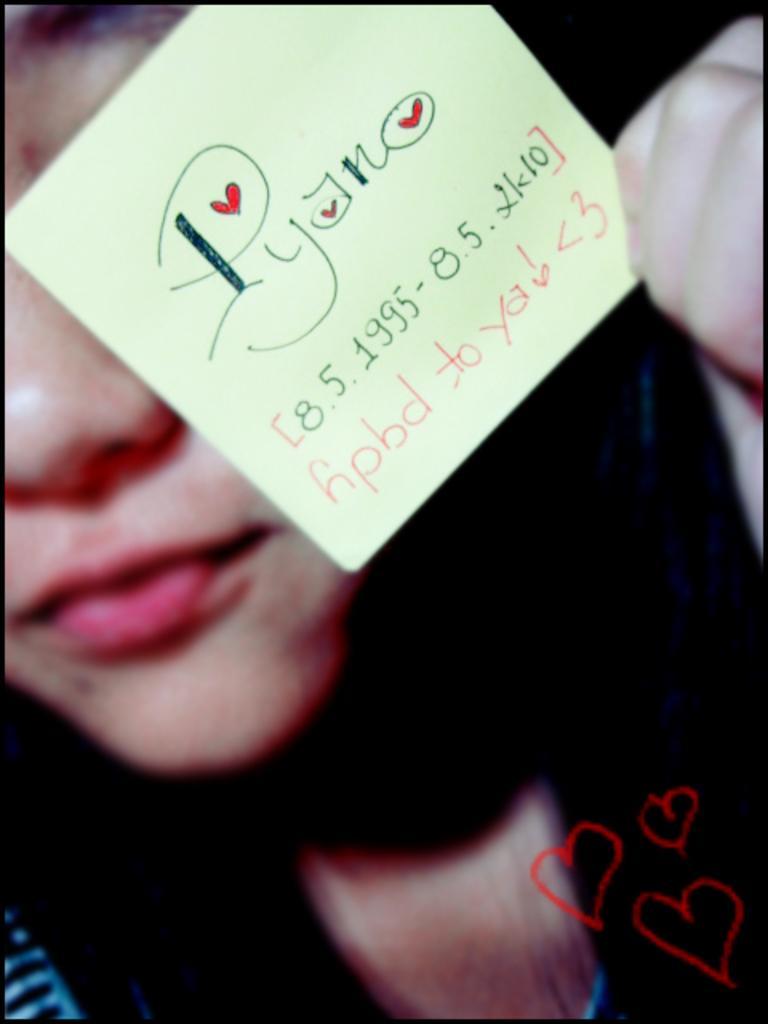Could you give a brief overview of what you see in this image? In this picture there is a woman holding the paper and there is a text and there are numbers on the paper. This picture is an edited picture. 